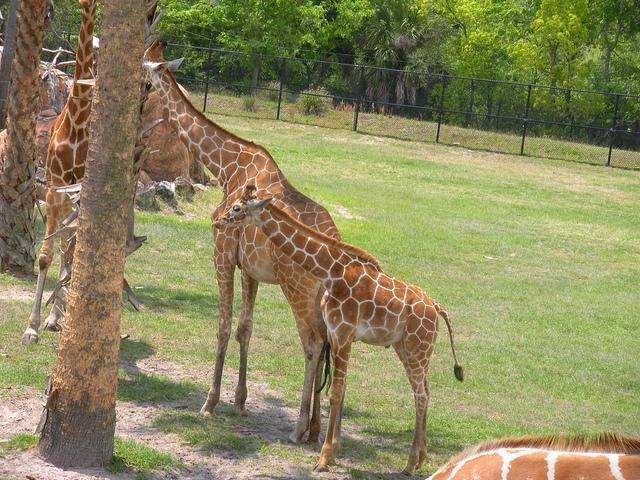How many giraffes can you see?
Give a very brief answer. 4. How many cows are there?
Give a very brief answer. 0. 